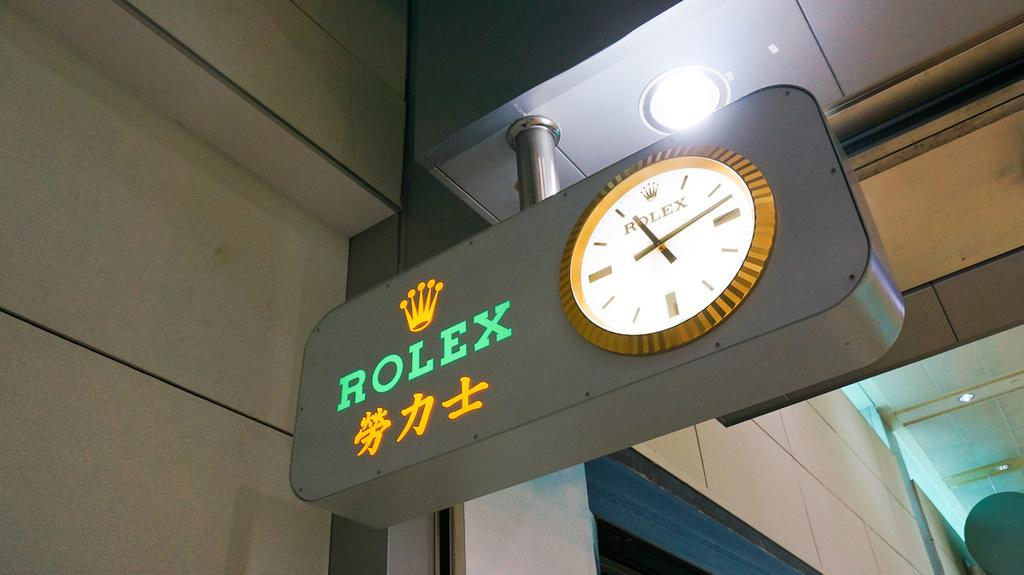<image>
Give a short and clear explanation of the subsequent image. A grey sign with a clock on it, and the brand Rolex to the left of the clock is suspended in the air. 